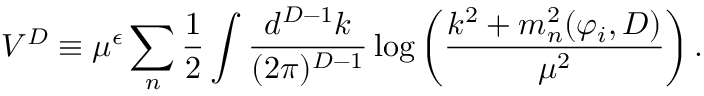<formula> <loc_0><loc_0><loc_500><loc_500>V ^ { D } \equiv \mu ^ { \epsilon } \sum _ { n } { \frac { 1 } { 2 } } \int { \frac { d ^ { D - 1 } k } { ( 2 \pi ) ^ { D - 1 } } } \log \left ( { \frac { k ^ { 2 } + m _ { n } ^ { 2 } ( \varphi _ { i } , D ) } { \mu ^ { 2 } } } \right ) .</formula> 